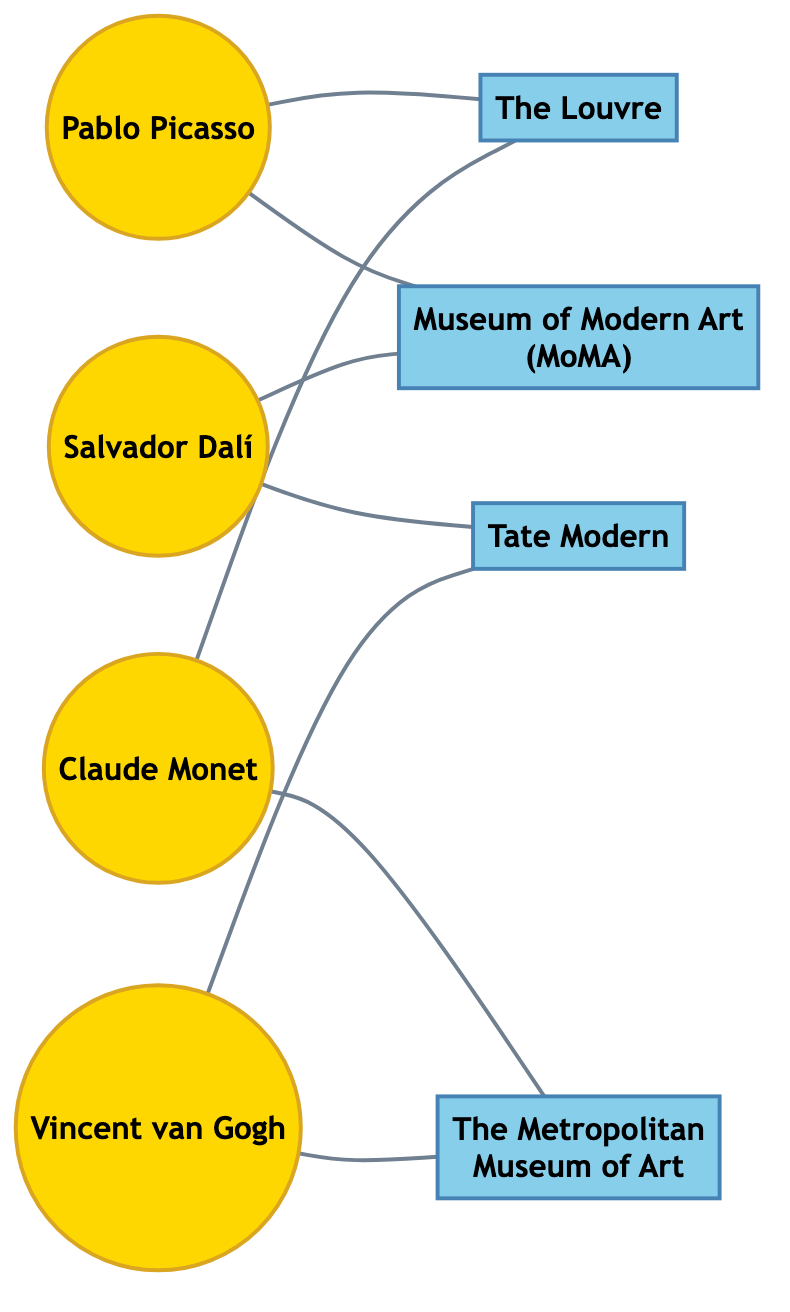What is the total number of artists in the diagram? The diagram includes four distinct artist nodes, each represented by a separate node in the network. Counting these nodes gives us the total number of artists.
Answer: 4 Which gallery is connected to both Pablo Picasso and Claude Monet? We can inspect the edges connected to both Pablo Picasso and Claude Monet. The Louvre is the only gallery linked to both artists.
Answer: The Louvre How many connections does Salvador Dalí have? By examining the connections (edges) emanating from Salvador Dalí's node, we see that he has two connections: one to MoMA and one to Tate Modern. This counts as two connections.
Answer: 2 Which artist collaborates with the most galleries? To find this, we look at the connections each artist has. Vincent van Gogh and Claude Monet each connect to two galleries, while Pablo Picasso and Salvador Dalí have fewer. This means they are tied for the most collaborations.
Answer: Vincent van Gogh and Claude Monet What is the total number of edges in the diagram? By counting each connection (edge) between the artist nodes and the gallery nodes, we find there are a total of eight edges connecting the nodes in the diagram.
Answer: 8 Which two galleries are exclusively connected to Vincent van Gogh? Checking Vincent van Gogh's connections, we find he has edges connecting only to Tate Modern and The Metropolitan Museum of Art, thus identifying these two galleries.
Answer: Tate Modern, The Metropolitan Museum of Art What is the relationship between Claude Monet and The Louvre? The edge connecting Claude Monet and The Louvre indicates that there is a direct relationship, meaning that Claude Monet has collaborated or exhibited at this gallery.
Answer: Direct relationship Which artist has the most connections to galleries? Analyzing the edges reveals both Vincent van Gogh and Claude Monet have connections to two separate galleries each, which is the highest number among all artists.
Answer: Vincent van Gogh and Claude Monet 